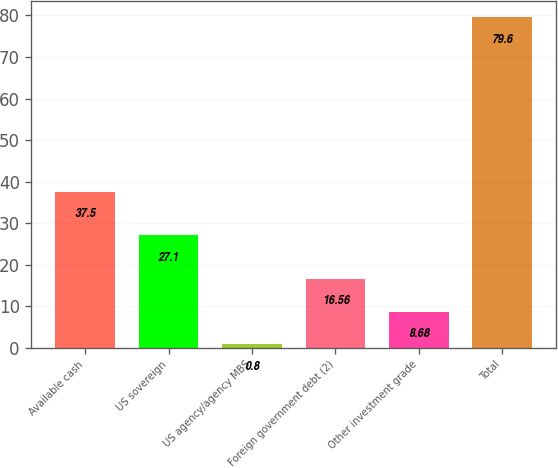<chart> <loc_0><loc_0><loc_500><loc_500><bar_chart><fcel>Available cash<fcel>US sovereign<fcel>US agency/agency MBS<fcel>Foreign government debt (2)<fcel>Other investment grade<fcel>Total<nl><fcel>37.5<fcel>27.1<fcel>0.8<fcel>16.56<fcel>8.68<fcel>79.6<nl></chart> 